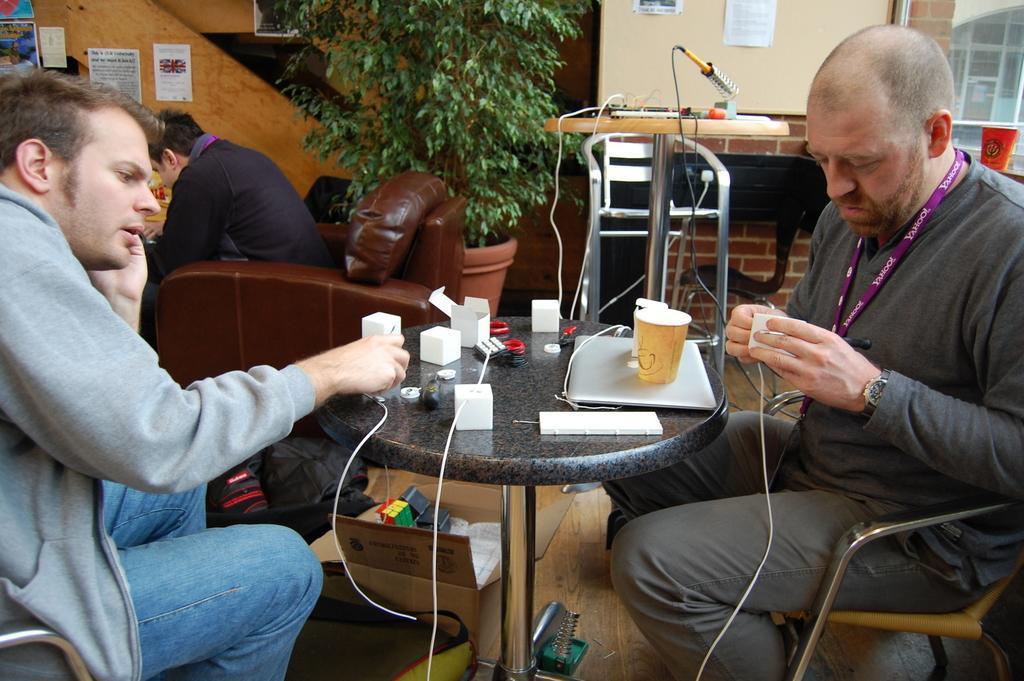Describe this image in one or two sentences. There are three persons sitting on the chairs. There is a small table with a laptop,tumbler and some objects placed on it. At the background I can see a flower pot with a plant in it. These are the posters attached to the wall. 